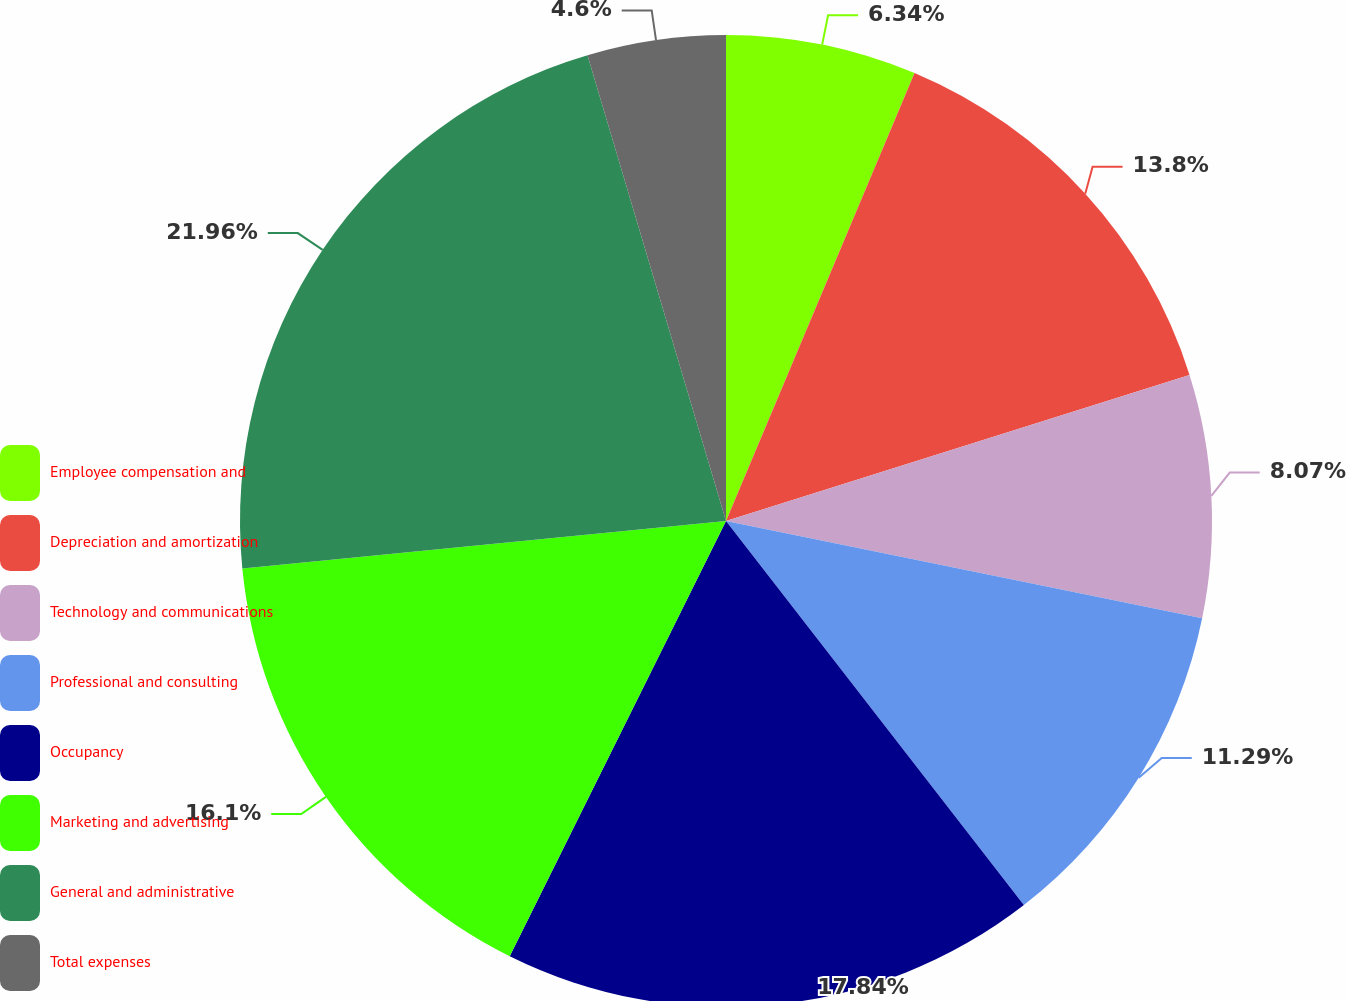Convert chart to OTSL. <chart><loc_0><loc_0><loc_500><loc_500><pie_chart><fcel>Employee compensation and<fcel>Depreciation and amortization<fcel>Technology and communications<fcel>Professional and consulting<fcel>Occupancy<fcel>Marketing and advertising<fcel>General and administrative<fcel>Total expenses<nl><fcel>6.34%<fcel>13.8%<fcel>8.07%<fcel>11.29%<fcel>17.84%<fcel>16.1%<fcel>21.96%<fcel>4.6%<nl></chart> 